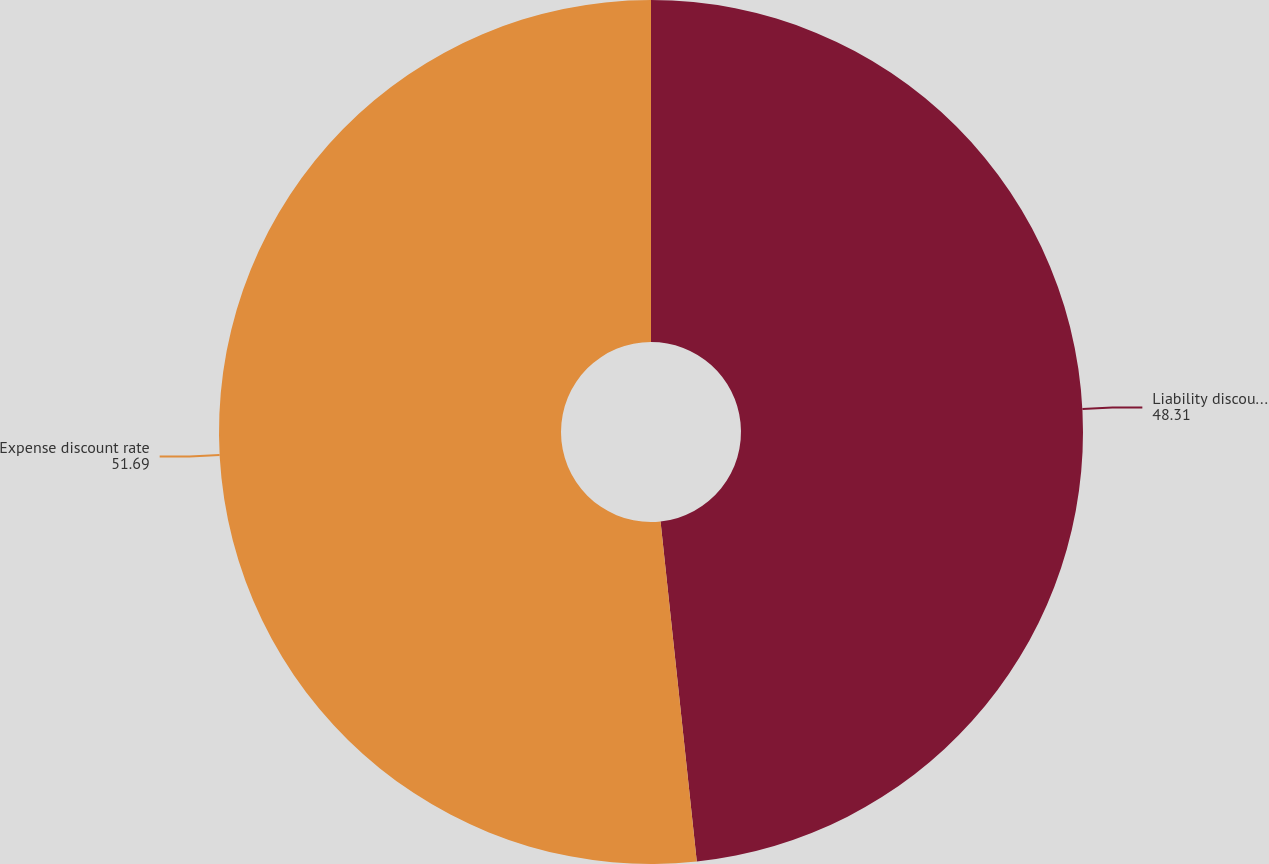Convert chart to OTSL. <chart><loc_0><loc_0><loc_500><loc_500><pie_chart><fcel>Liability discount rate<fcel>Expense discount rate<nl><fcel>48.31%<fcel>51.69%<nl></chart> 